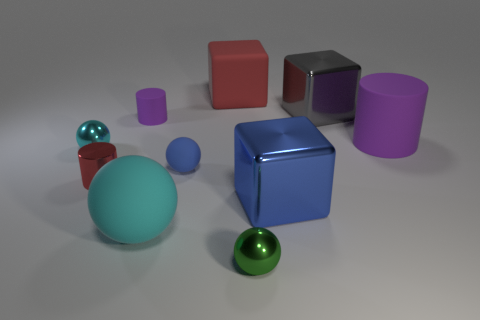Is the small rubber cylinder the same color as the big cylinder?
Make the answer very short. Yes. The small metallic thing that is the same color as the large matte ball is what shape?
Offer a very short reply. Sphere. Do the shiny ball that is behind the cyan matte ball and the big matte thing that is in front of the big purple cylinder have the same color?
Make the answer very short. Yes. There is a rubber cylinder right of the small metallic ball that is to the right of the large cyan object; what is its color?
Offer a very short reply. Purple. Are there any green matte cylinders?
Offer a terse response. No. There is a small sphere that is in front of the cyan metallic ball and left of the tiny green metal ball; what color is it?
Offer a terse response. Blue. Does the shiny ball that is in front of the small blue rubber object have the same size as the blue object right of the green metal object?
Make the answer very short. No. There is a tiny cylinder in front of the tiny purple cylinder; what number of metallic objects are in front of it?
Make the answer very short. 2. Are there fewer small red cylinders that are behind the big purple thing than red things?
Provide a succinct answer. Yes. What shape is the large shiny thing in front of the small matte object to the left of the blue matte sphere that is in front of the large cylinder?
Offer a terse response. Cube. 